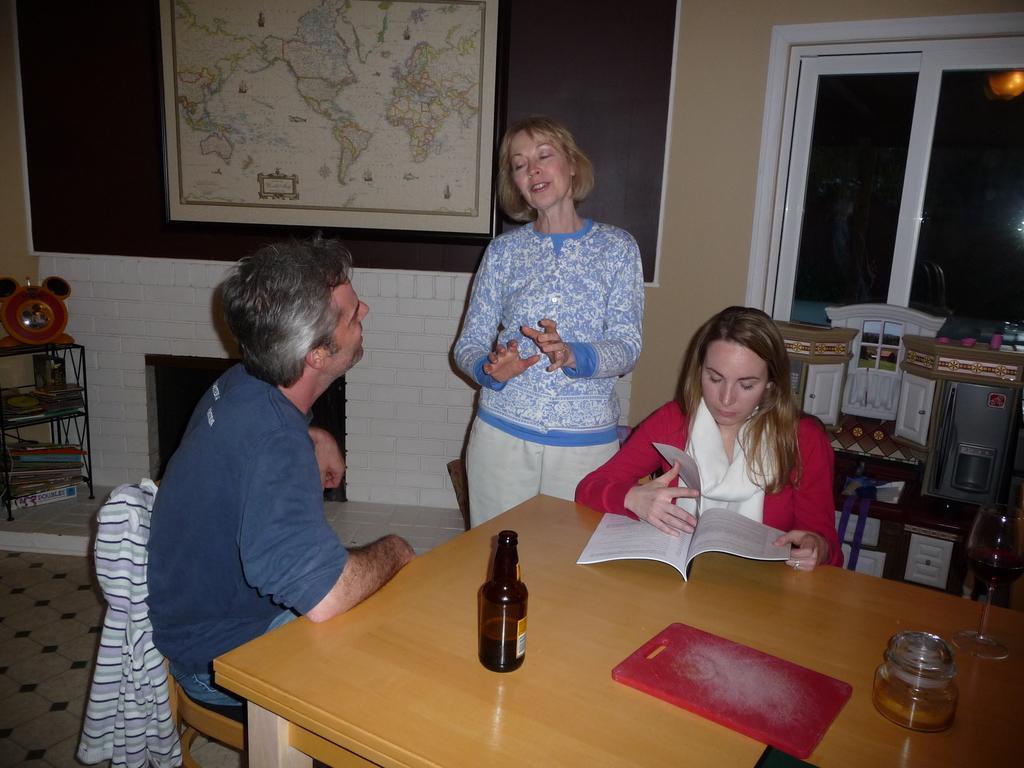Please provide a concise description of this image. In this image there are 3 persons, in which 2 of them are women and one of them is a man and I can also see that 2 of them are sitting on the chairs and there is a table in front and there is bottle and a glass on it. In the background i can see the window, a map and the few things over here. 